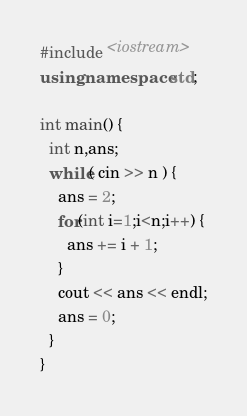Convert code to text. <code><loc_0><loc_0><loc_500><loc_500><_C++_>#include <iostream>
using namespace std;

int main() {
  int n,ans;
  while( cin >> n ) {
    ans = 2;
    for(int i=1;i<n;i++) {
      ans += i + 1;
    }
    cout << ans << endl;
    ans = 0;
  }
}</code> 